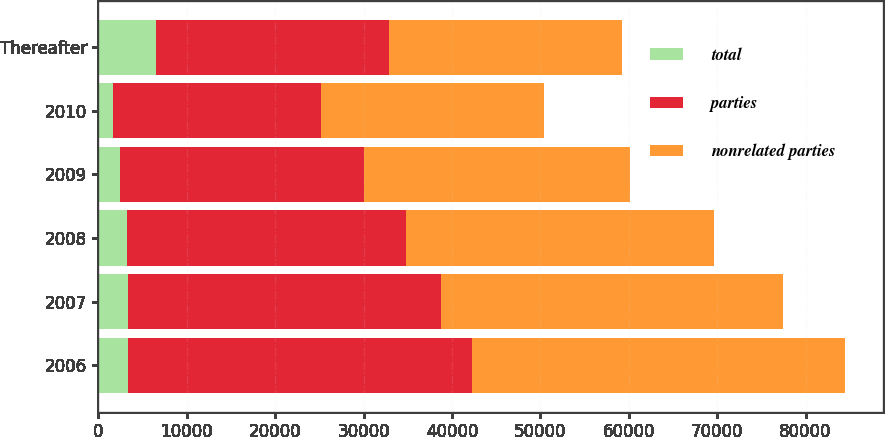Convert chart. <chart><loc_0><loc_0><loc_500><loc_500><stacked_bar_chart><ecel><fcel>2006<fcel>2007<fcel>2008<fcel>2009<fcel>2010<fcel>Thereafter<nl><fcel>total<fcel>3349<fcel>3351<fcel>3277<fcel>2480<fcel>1678<fcel>6462<nl><fcel>parties<fcel>38902<fcel>35359<fcel>31568<fcel>27564<fcel>23515<fcel>26378.5<nl><fcel>nonrelated parties<fcel>42251<fcel>38710<fcel>34845<fcel>30044<fcel>25193<fcel>26378.5<nl></chart> 